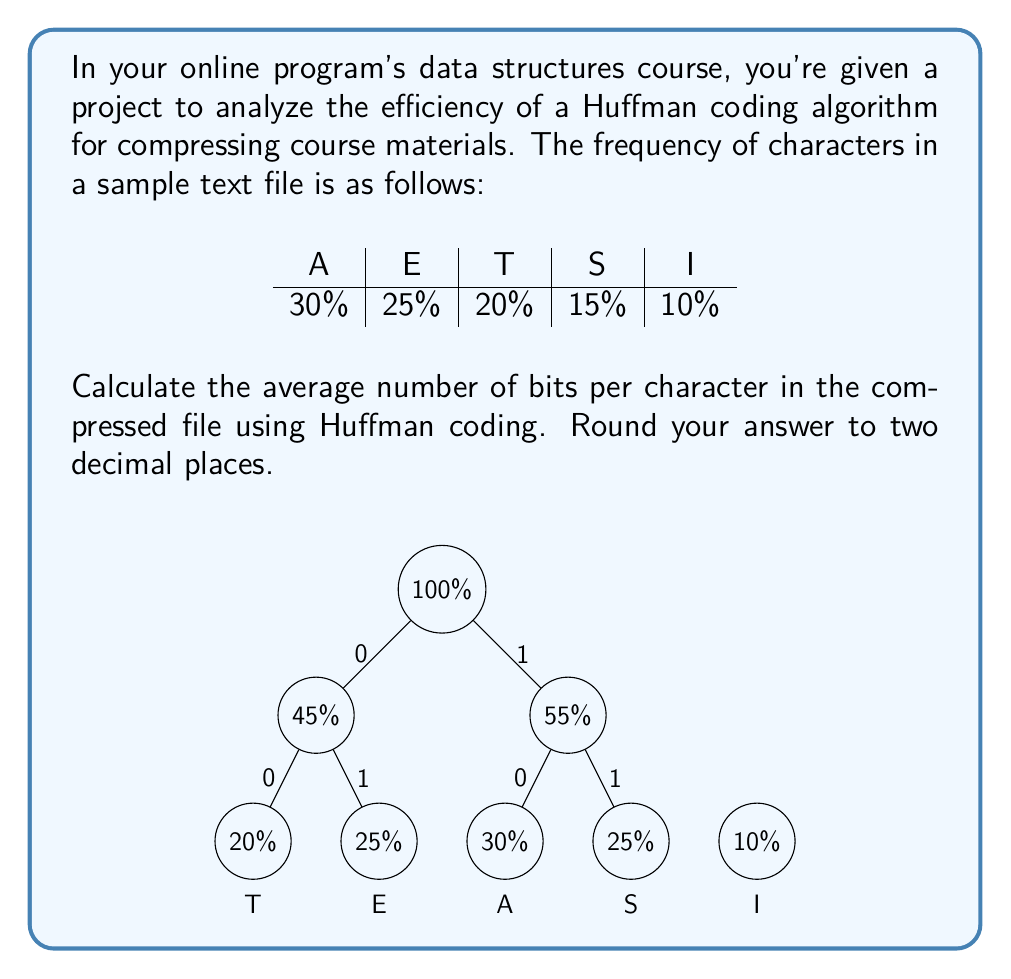Help me with this question. Let's approach this step-by-step:

1) First, we need to construct the Huffman tree (as shown in the diagram).

2) From the tree, we can determine the bit codes for each character:
   A: 10
   E: 01
   T: 000
   S: 11
   I: 001

3) Now, we calculate the number of bits for each character:
   A: 2 bits
   E: 2 bits
   T: 3 bits
   S: 2 bits
   I: 3 bits

4) To find the average number of bits, we multiply each character's frequency by its number of bits and sum:

   $$ \text{Average} = (0.30 \times 2) + (0.25 \times 2) + (0.20 \times 3) + (0.15 \times 2) + (0.10 \times 3) $$

5) Let's calculate:
   $$ \text{Average} = 0.60 + 0.50 + 0.60 + 0.30 + 0.30 = 2.30 $$

6) Rounding to two decimal places: 2.30 bits per character.

This result shows that, on average, each character in the compressed file will be represented by 2.30 bits, which is more efficient than using a fixed 3-bit encoding for 5 characters.
Answer: 2.30 bits 